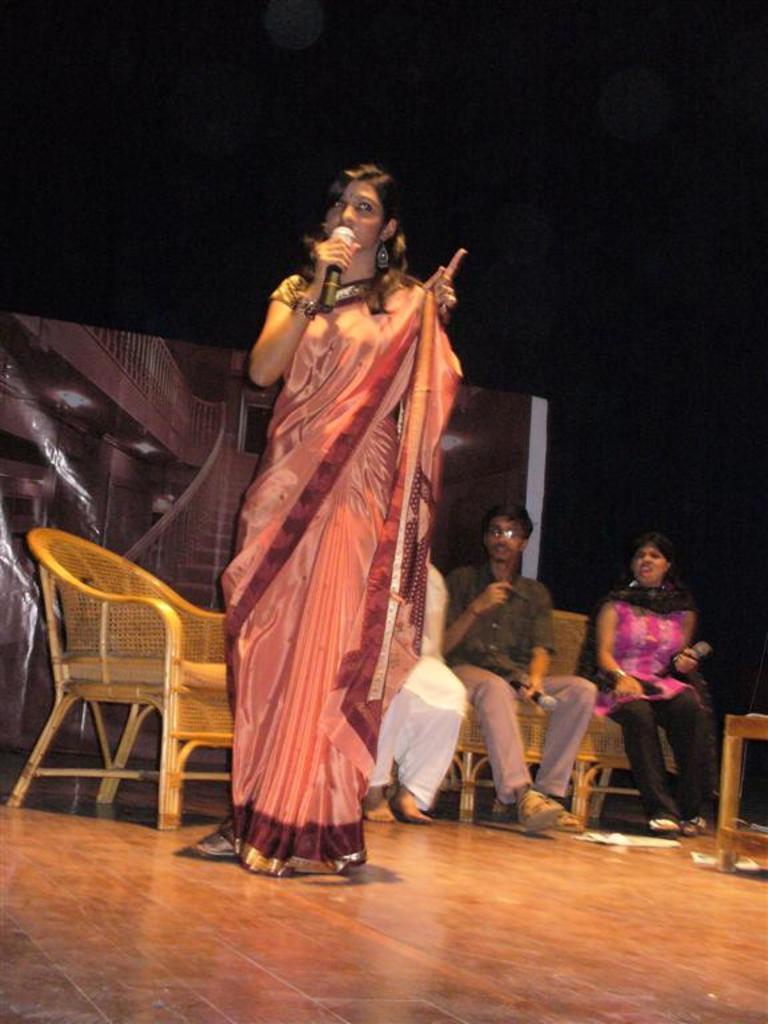How would you summarize this image in a sentence or two? In this image, woman in a saree is standing. She hold a microphone on his hand. There is a floor. The background, few peoples are sat on the sofa. Here there is a chair. At the background, we can see a banner. The right side, we can see a wooden table. 